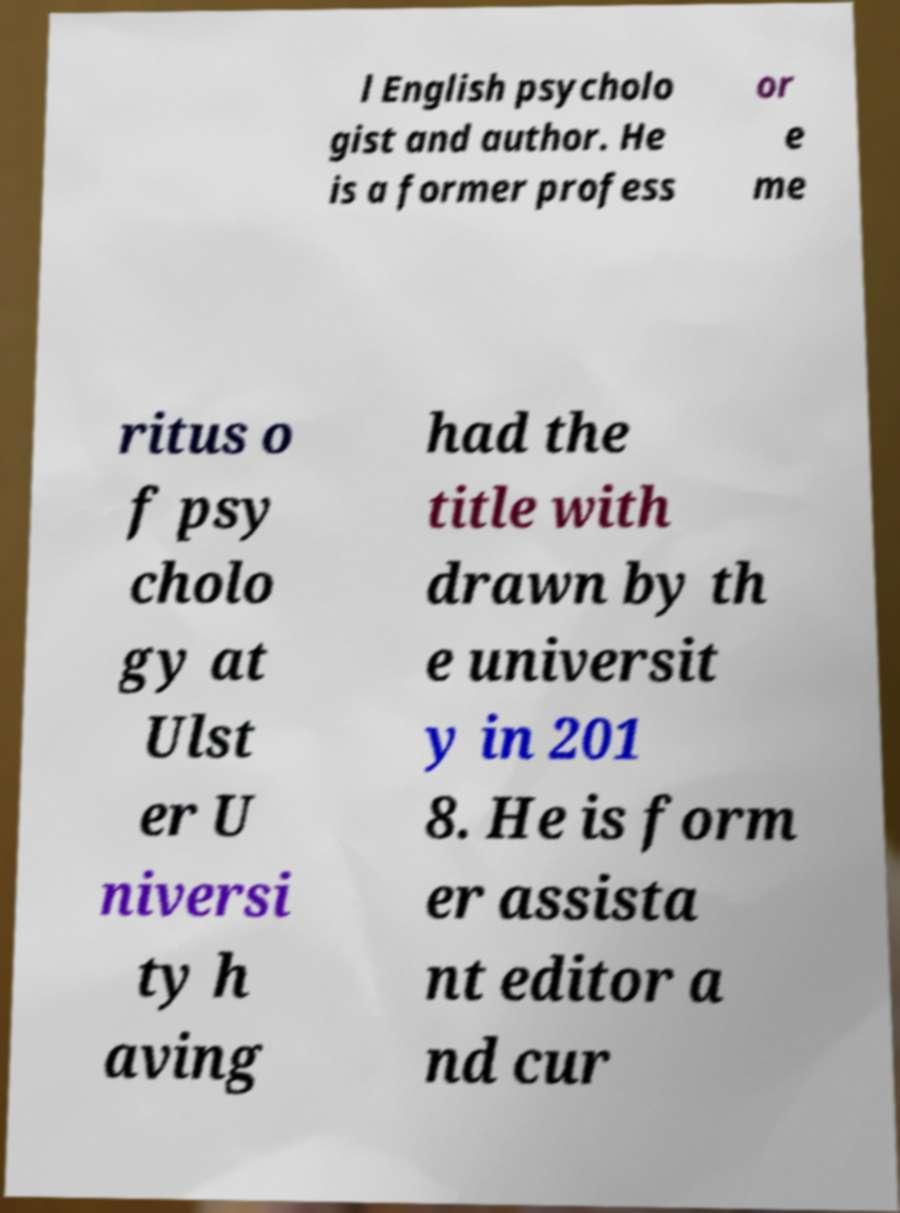Can you read and provide the text displayed in the image?This photo seems to have some interesting text. Can you extract and type it out for me? l English psycholo gist and author. He is a former profess or e me ritus o f psy cholo gy at Ulst er U niversi ty h aving had the title with drawn by th e universit y in 201 8. He is form er assista nt editor a nd cur 